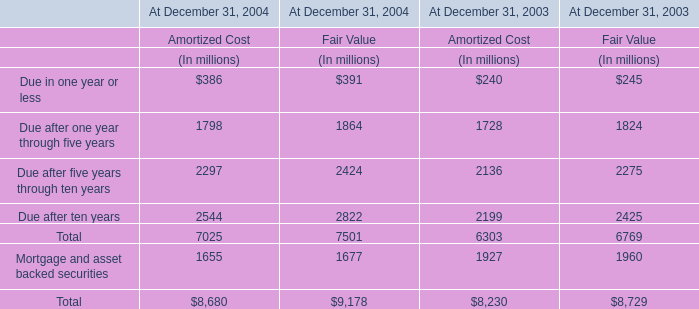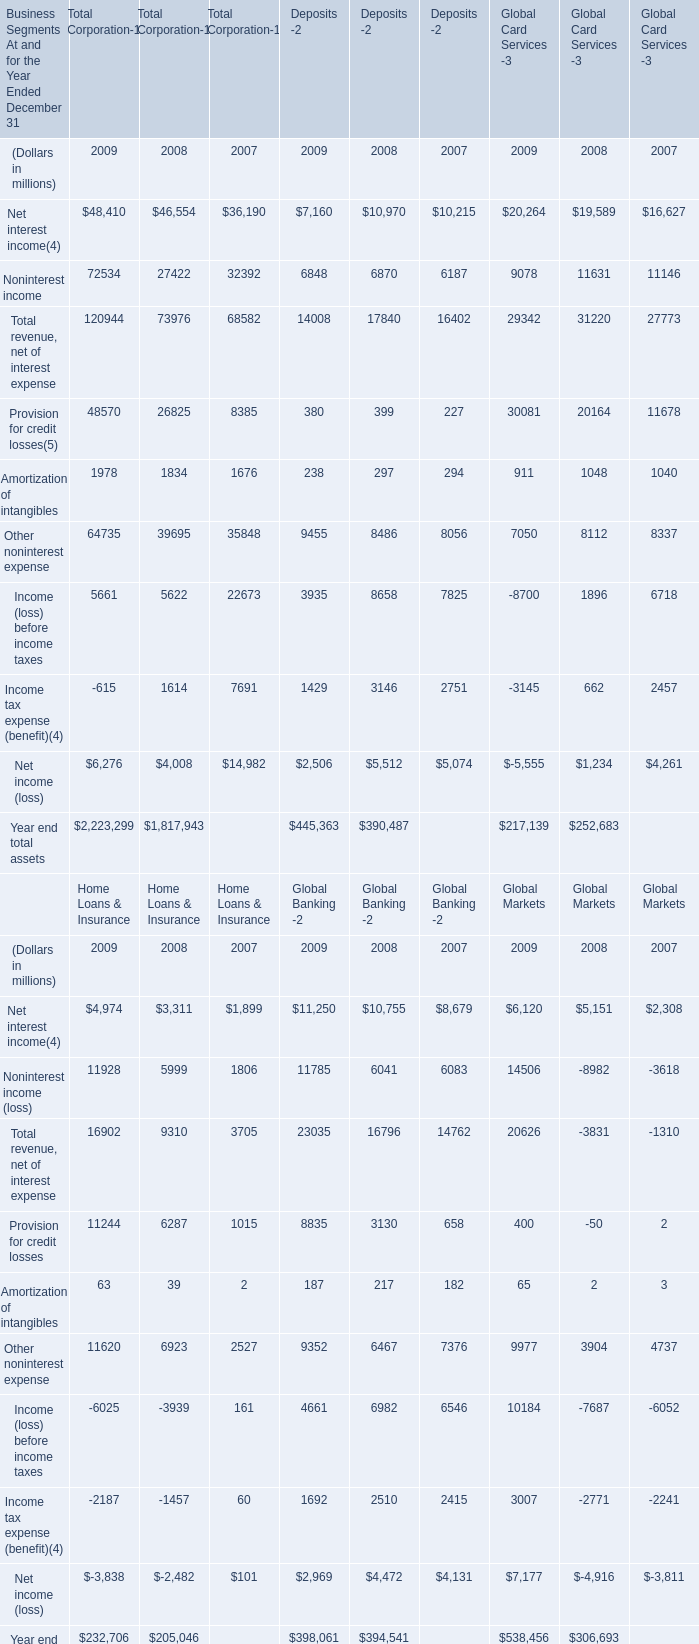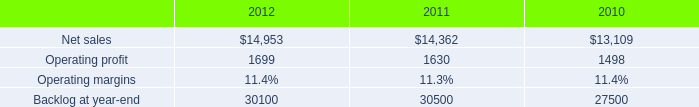What's the average of Net interest income in 2009? (in million) 
Computations: (((48410 + 7160) + 20264) / 3)
Answer: 25278.0. 